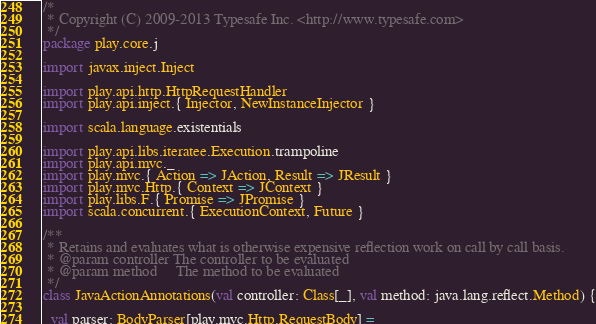<code> <loc_0><loc_0><loc_500><loc_500><_Scala_>/*
 * Copyright (C) 2009-2013 Typesafe Inc. <http://www.typesafe.com>
 */
package play.core.j

import javax.inject.Inject

import play.api.http.HttpRequestHandler
import play.api.inject.{ Injector, NewInstanceInjector }

import scala.language.existentials

import play.api.libs.iteratee.Execution.trampoline
import play.api.mvc._
import play.mvc.{ Action => JAction, Result => JResult }
import play.mvc.Http.{ Context => JContext }
import play.libs.F.{ Promise => JPromise }
import scala.concurrent.{ ExecutionContext, Future }

/**
 * Retains and evaluates what is otherwise expensive reflection work on call by call basis.
 * @param controller The controller to be evaluated
 * @param method     The method to be evaluated
 */
class JavaActionAnnotations(val controller: Class[_], val method: java.lang.reflect.Method) {

  val parser: BodyParser[play.mvc.Http.RequestBody] =</code> 